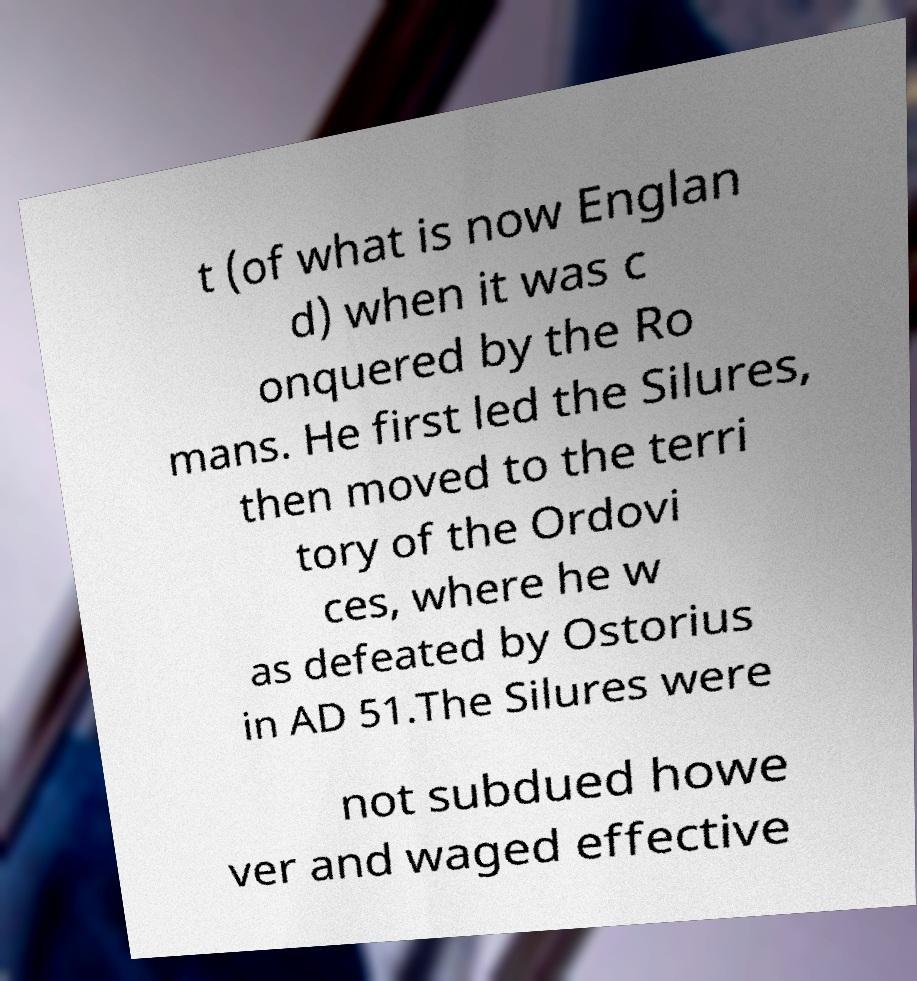Could you assist in decoding the text presented in this image and type it out clearly? t (of what is now Englan d) when it was c onquered by the Ro mans. He first led the Silures, then moved to the terri tory of the Ordovi ces, where he w as defeated by Ostorius in AD 51.The Silures were not subdued howe ver and waged effective 